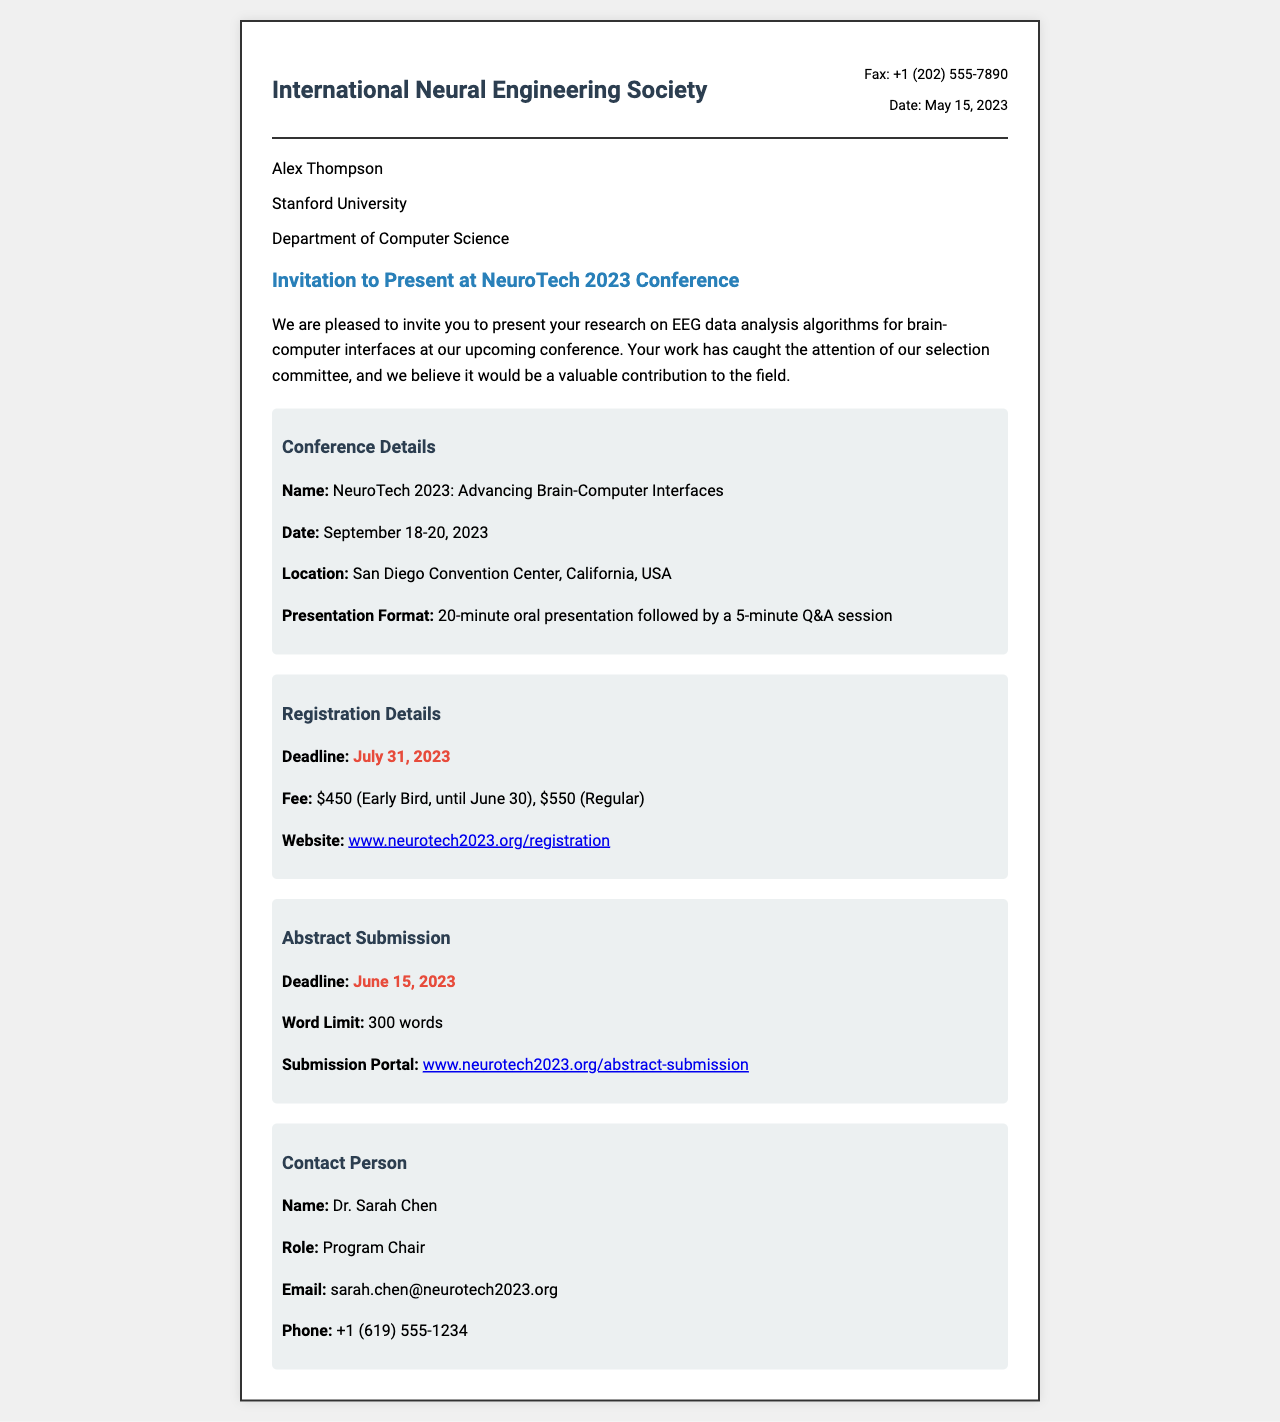What is the name of the conference? The name of the conference is mentioned in the document as "NeuroTech 2023: Advancing Brain-Computer Interfaces."
Answer: NeuroTech 2023: Advancing Brain-Computer Interfaces When is the conference scheduled? The document states that the conference will take place from September 18-20, 2023.
Answer: September 18-20, 2023 What is the deadline for abstract submission? The document provides a specific date for the abstract submission deadline, which is June 15, 2023.
Answer: June 15, 2023 Who is the contact person for the conference? The document specifies that the contact person is Dr. Sarah Chen, who is the Program Chair.
Answer: Dr. Sarah Chen What is the registration fee for early bird registration? The document mentions that the early bird registration fee is $450 until June 30.
Answer: $450 How long is the presentation format? The document states that the presentation format consists of a 20-minute oral presentation followed by a 5-minute Q&A session.
Answer: 20 minutes What is the registration deadline? The document clearly mentions that the registration deadline is July 31, 2023.
Answer: July 31, 2023 What is the word limit for the abstract? The document specifies that the word limit for the abstract submission is 300 words.
Answer: 300 words What is the submission portal URL for abstract submission? The document provides the URL for the abstract submission portal as "www.neurotech2023.org/abstract-submission."
Answer: www.neurotech2023.org/abstract-submission 